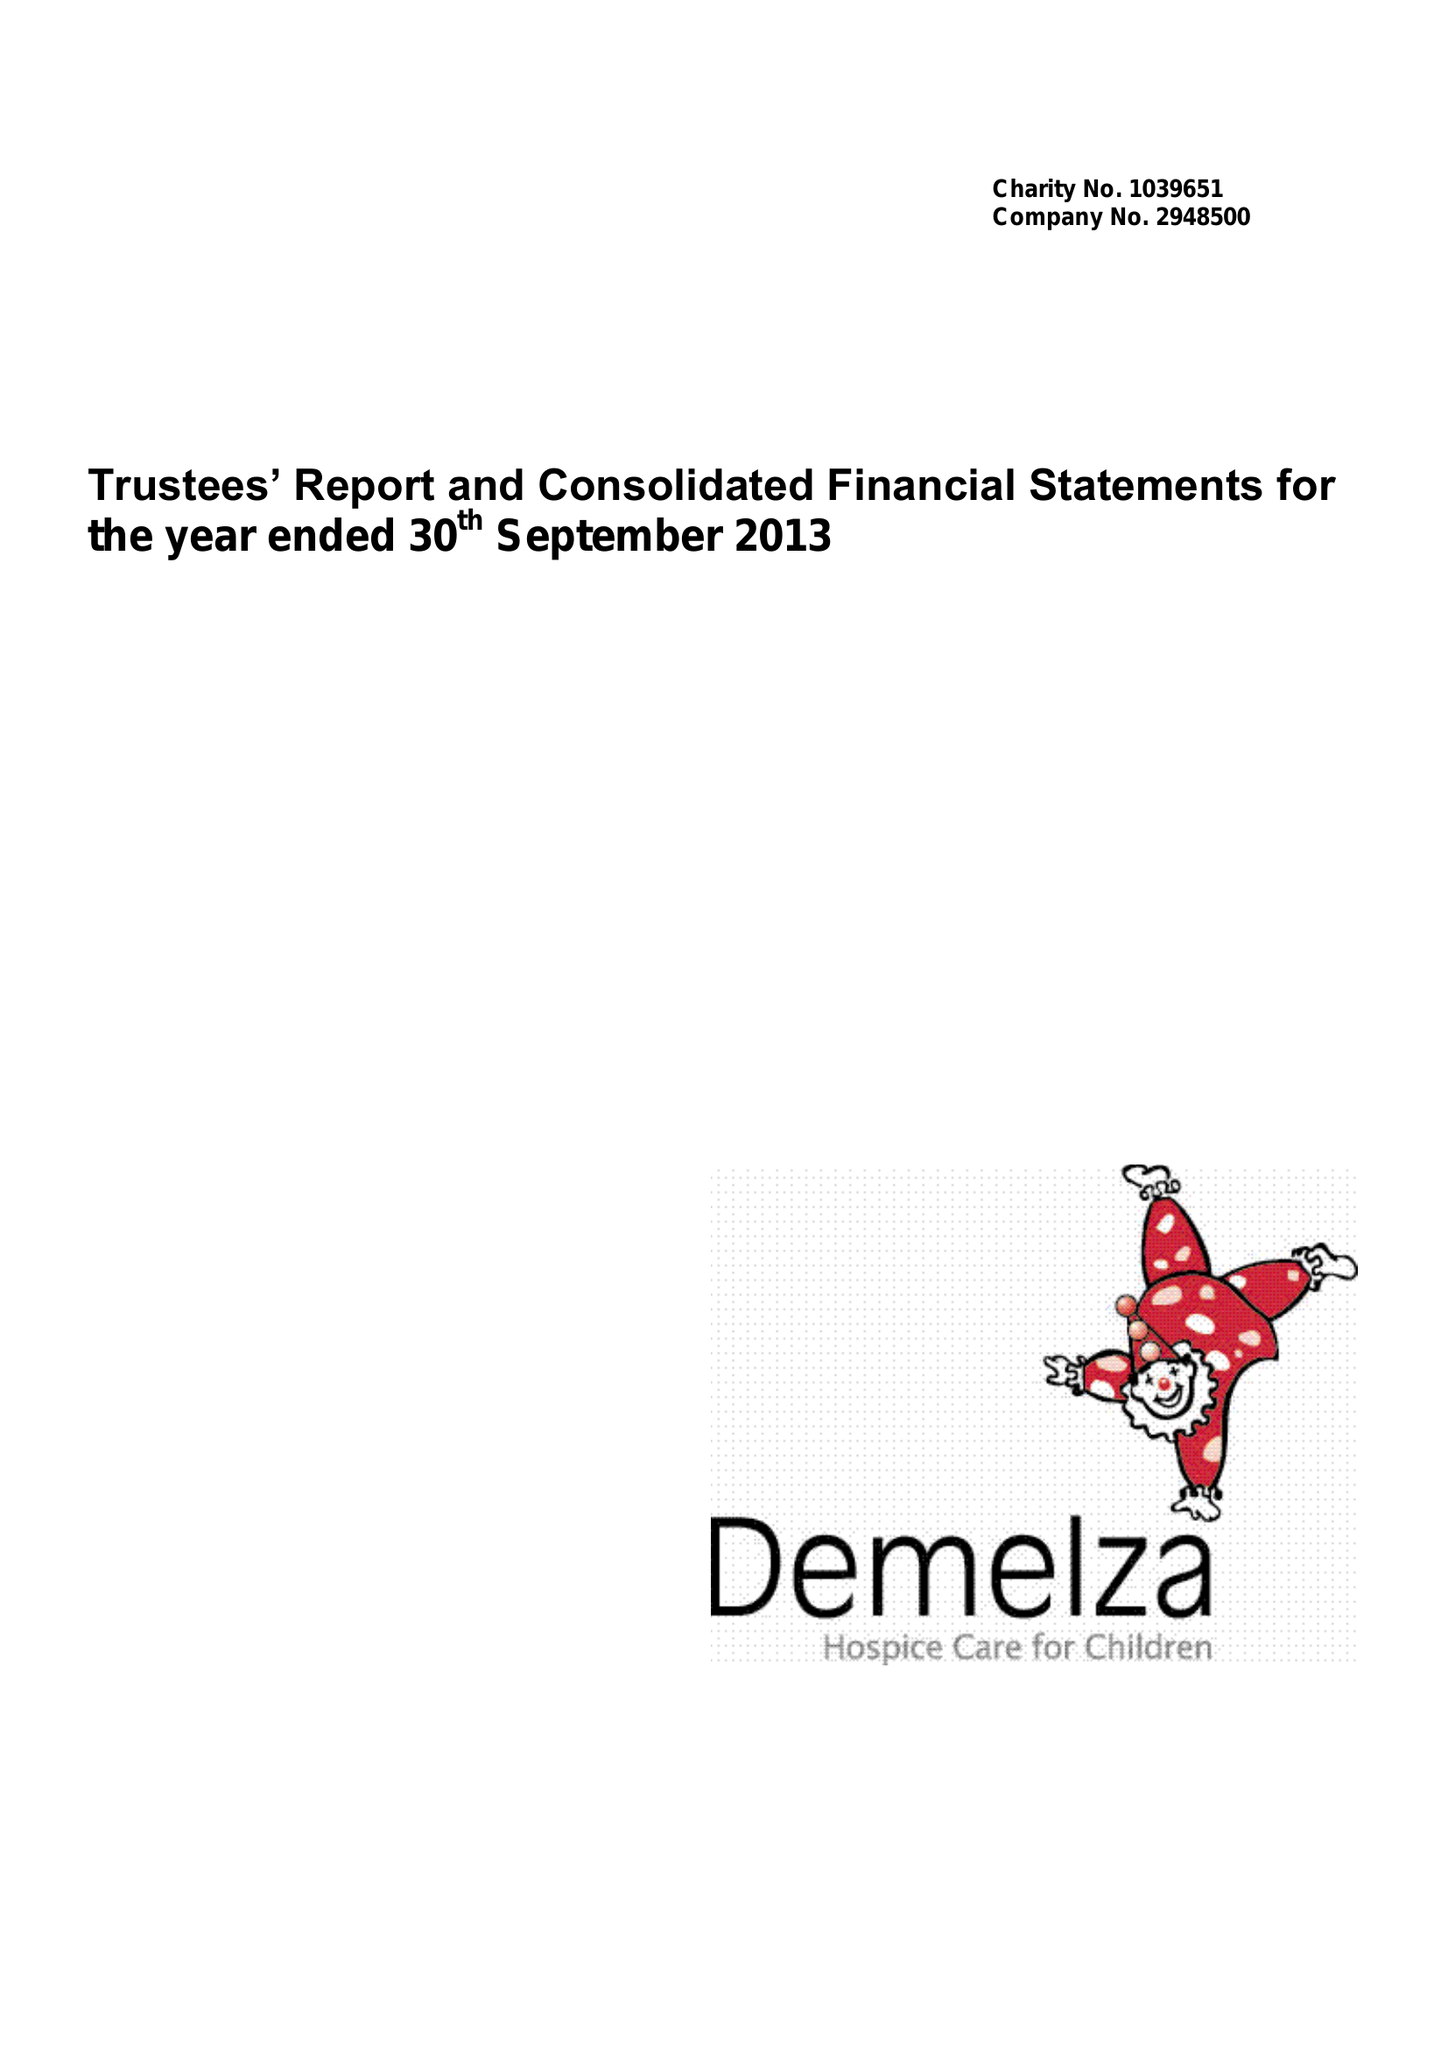What is the value for the income_annually_in_british_pounds?
Answer the question using a single word or phrase. 9654149.00 